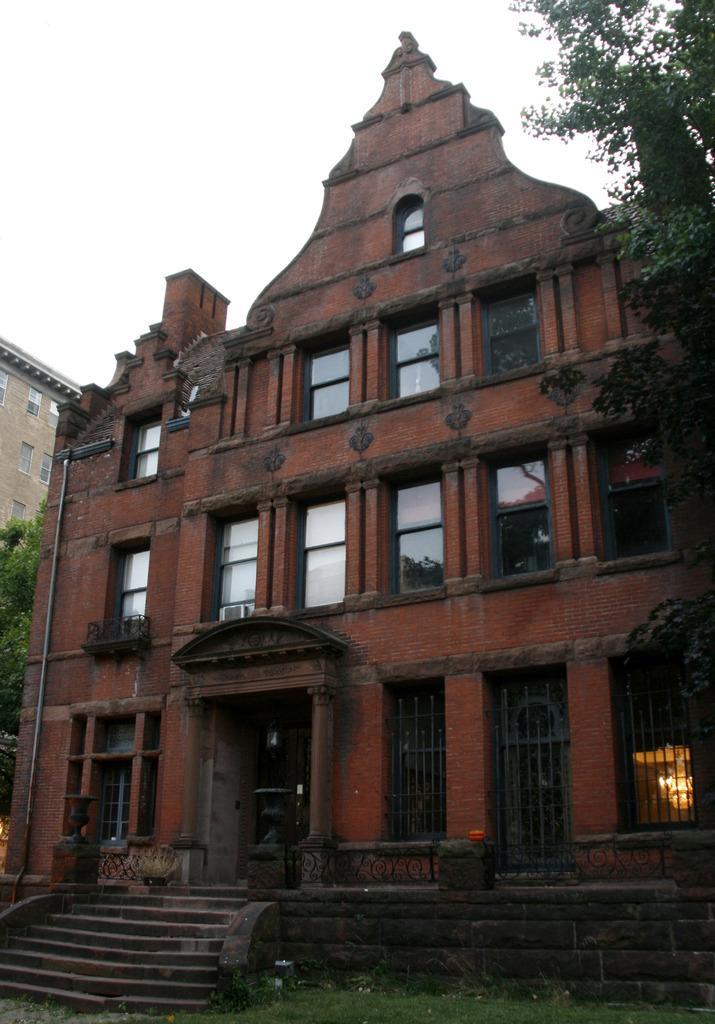Please provide a concise description of this image. In this image I can see grass, stairs few buildings and few trees. 